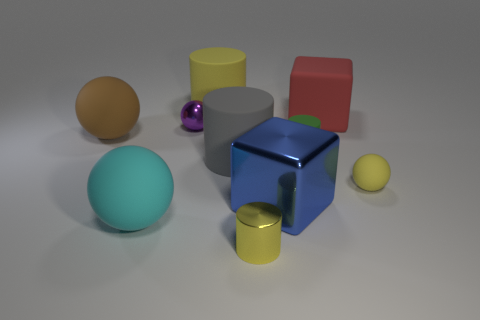There is a small metallic ball; is its color the same as the cylinder behind the brown rubber sphere?
Your response must be concise. No. Is there any other thing that is the same material as the yellow ball?
Ensure brevity in your answer.  Yes. The large blue shiny thing is what shape?
Your response must be concise. Cube. What size is the yellow matte thing that is right of the big cylinder that is behind the red thing?
Offer a terse response. Small. Are there the same number of big matte objects behind the large yellow rubber cylinder and small yellow shiny cylinders on the left side of the tiny shiny cylinder?
Keep it short and to the point. Yes. There is a thing that is both in front of the small rubber sphere and behind the cyan matte thing; what is it made of?
Ensure brevity in your answer.  Metal. There is a cyan rubber object; is its size the same as the yellow rubber object behind the small yellow rubber ball?
Your answer should be very brief. Yes. What number of other objects are the same color as the metal ball?
Give a very brief answer. 0. Is the number of tiny yellow shiny things behind the red thing greater than the number of large red objects?
Offer a very short reply. No. The small cylinder that is right of the yellow cylinder in front of the big cylinder that is in front of the brown rubber object is what color?
Your answer should be very brief. Green. 